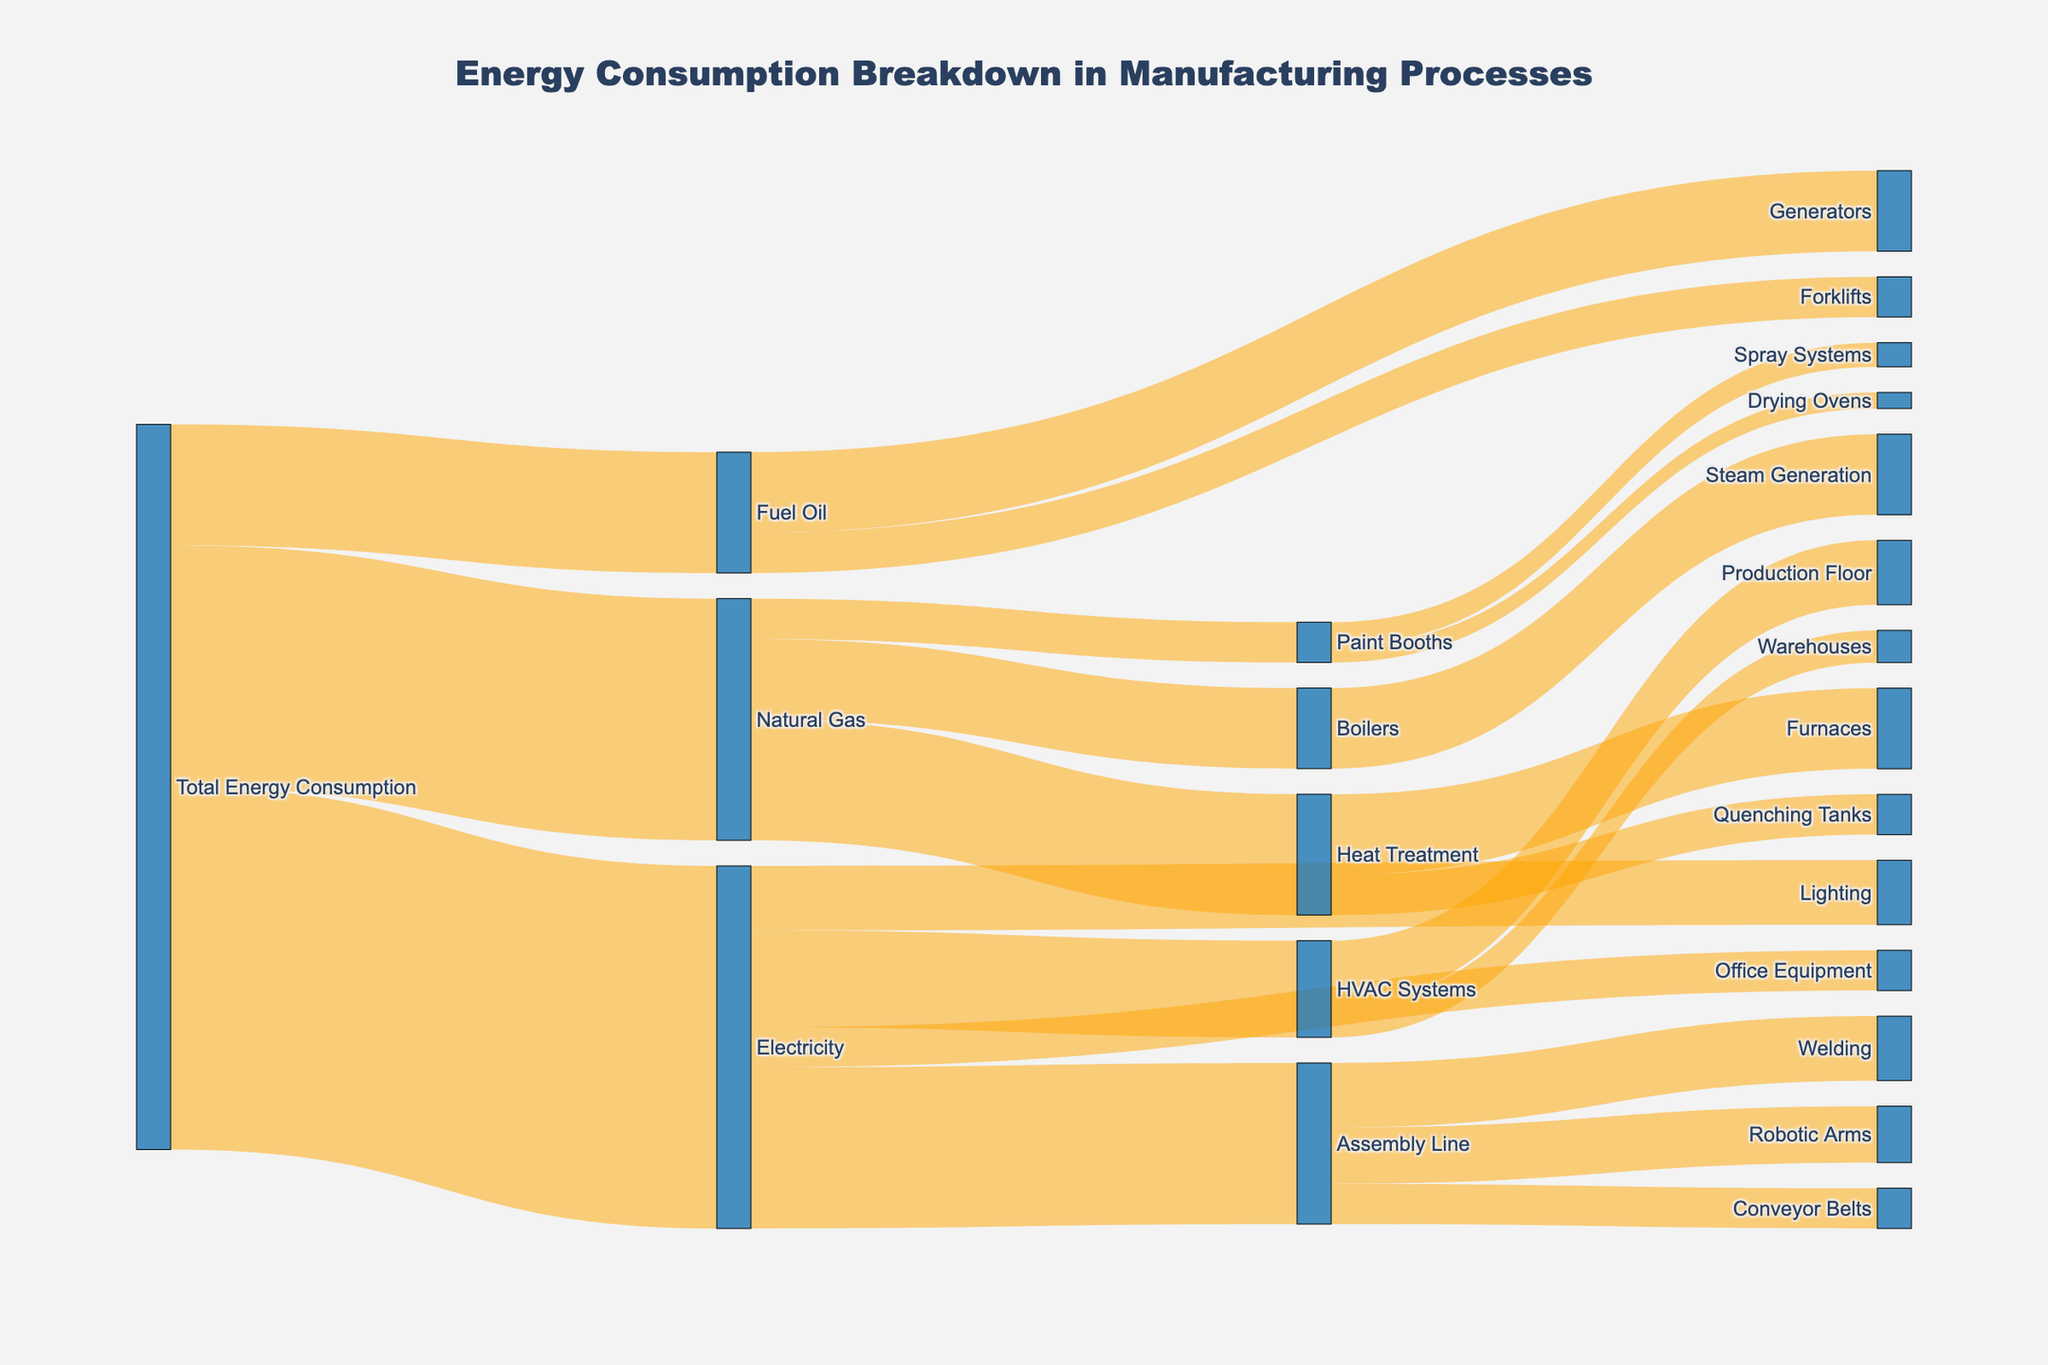What is the total amount of electricity used by the Assembly Line? According to the figure, the Assembly Line uses electricity, and the energy consumption is indicated by the connections between nodes. The value for electricity used by the Assembly Line is given as 200 units.
Answer: 200 Which manufacturing process consumes the most natural gas? By observing the connections from the Natural Gas node to various processes, we see that Heat Treatment, Boilers, and Paint Booths are the processes listed. Heat Treatment has the highest consumption with 150 units.
Answer: Heat Treatment How much energy does Fuel Oil contribute to Forklifts? The Sankey diagram shows the flow of energy from Fuel Oil to Generators and Forklifts. From Fuel Oil to Forklifts, the value is 50 units.
Answer: 50 What is the combined energy consumption of HVAC Systems and Office Equipment under electricity? The diagram shows that HVAC Systems consume 120 units and Office Equipment consumes 50 units. Adding these gives 120 + 50 = 170 units.
Answer: 170 Which energy source has the smallest total consumption? By looking at the initial breakdown, the energy sources listed are Electricity, Natural Gas, and Fuel Oil. Fuel Oil has the smallest consumption with 150 units.
Answer: Fuel Oil Between Assembly Line and Lighting, which uses more electricity and by how much? The Assembly Line uses 200 units, while Lighting uses 80 units. The difference is 200 - 80 = 120 units. Therefore, the Assembly Line uses 120 units more electricity than Lighting.
Answer: Assembly Line by 120 How much total energy is used by the Paint Booths? The total energy used by Paint Booths is the sum of energy from Natural Gas and its further consumption. From Natural Gas to Paint Booths is 50 units, and within Paint Booths, Spray Systems use 30 units and Drying Ovens use 20 units. Summing these gives 50 units.
Answer: 50 What fraction of the total energy consumption is from Natural Gas to Manufacturing Processes? Natural Gas has a total consumption of 300 units. This consists of 150 units for Heat Treatment, 100 units for Boilers, and 50 units for Paint Booths. The fraction is still 300 out of total 900 units of Total Energy Consumption.
Answer: 300/900 or 1/3 What is the biggest user of energy within the Assembly Line? Inside the Assembly Line, the diagram shows that Welding, Robotic Arms, and Conveyor Belts are significant users. Welding uses the most with 80 units.
Answer: Welding Looks like there are multiple facilities consuming energy: How much aggregate energy does Heat Treatment use? Heat Treatment consists of Furnaces and Quenching Tanks, using 100 and 50 units respectively. Adding these, Heat Treatment uses a total of 150 units.
Answer: 150 